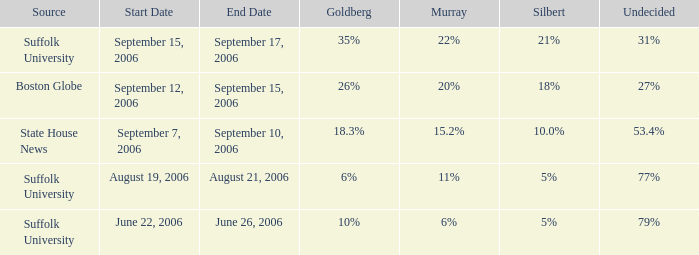What is the date of the poll with Silbert at 10.0%? September 7–10, 2006. 